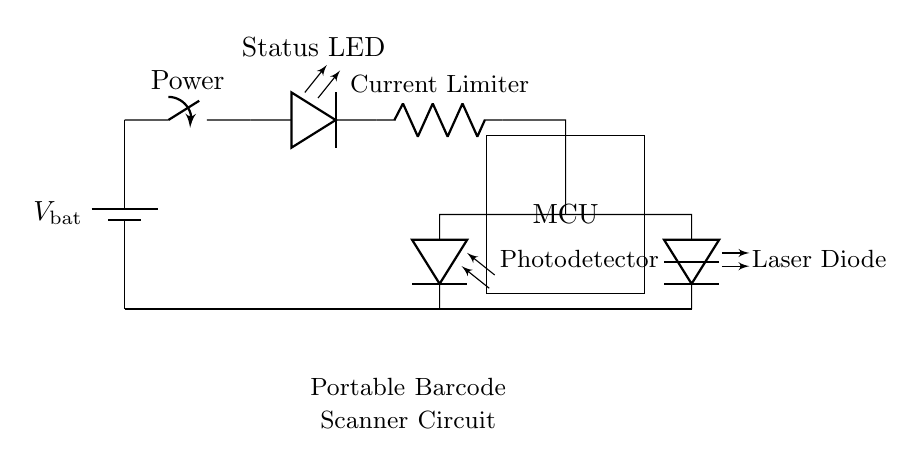What is the voltage source type in this circuit? The circuit features a battery as its voltage source, indicated by the symbol at the top left of the diagram, labeled V_bat.
Answer: battery What component limits the current in this circuit? The diagram includes a component labeled "Current Limiter" which is a resistor, positioned between the LED and the microcontroller, serving to restrict the current flow.
Answer: resistor How many main components does the circuit have? The circuit shows a total of six main components: a battery, a switch, an LED, a resistor, a microcontroller, and a laser diode/photodiode. This count includes both the laser diode and photodiode as separate functional components.
Answer: six What is the purpose of the Status LED in this circuit? The Status LED is used to indicate the operational state of the circuit, commonly showing whether the scanner is powered on or off, which can be inferred from its position directly in line after the switch.
Answer: operational indicator Which component detects the laser light in this circuit? The component named "Photodetector" is utilized for detecting the laser light emitted from the laser diode. It is positioned parallel to the laser diode, thereby effectively capturing the reflected light for processing.
Answer: photodetector What is the sequence of activation in this circuit? The sequence begins with activating the switch, allowing current from the battery to flow to the LED, which illuminates and signals power to the microcontroller, subsequently enabling its operation and activating both the laser diode and photodiode.
Answer: switch, LED, MCU, laser diode, photodetector What type of circuit is illustrated here? The circuit is a series circuit because the components are connected in a single path, meaning all current flows through each component sequentially, as shown in the layout of the parts.
Answer: series 